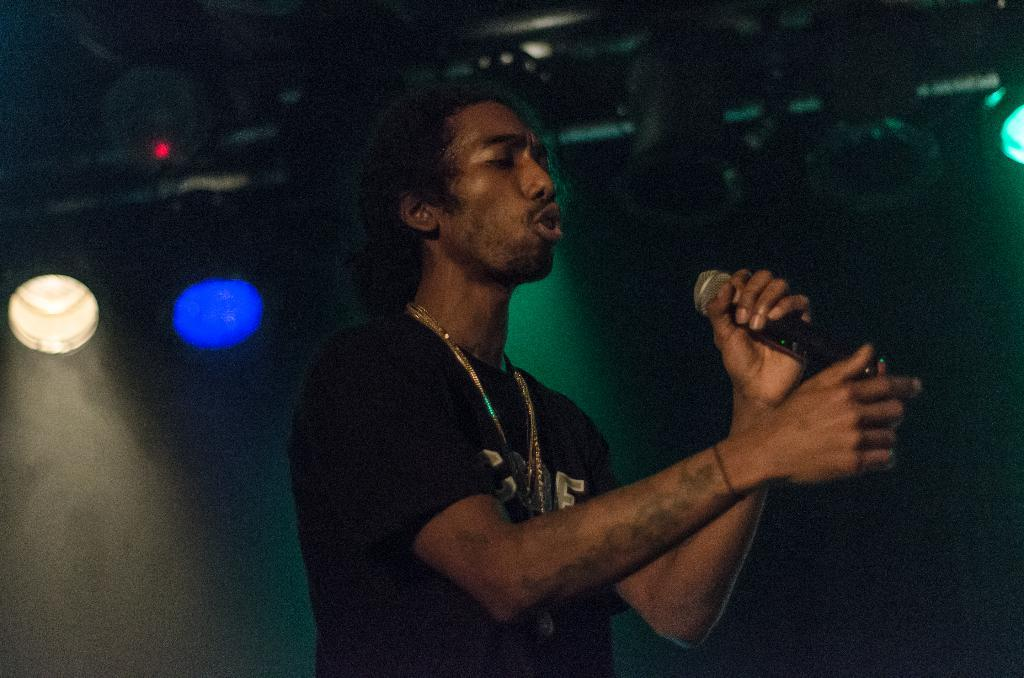What is the person in the image doing? The person is standing and singing in the image. What is the person holding in his hand? The person is holding a mic in his hand. What can be seen in the background of the image? There are lights in the background of the image. What type of border can be seen around the person in the image? There is no border visible around the person in the image. Are there any clams or lettuce present in the image? No, there are no clams or lettuce present in the image. 